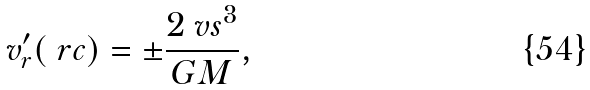Convert formula to latex. <formula><loc_0><loc_0><loc_500><loc_500>v _ { r } ^ { \prime } ( \ r c ) = \pm \frac { 2 \ v s ^ { 3 } } { G M } ,</formula> 